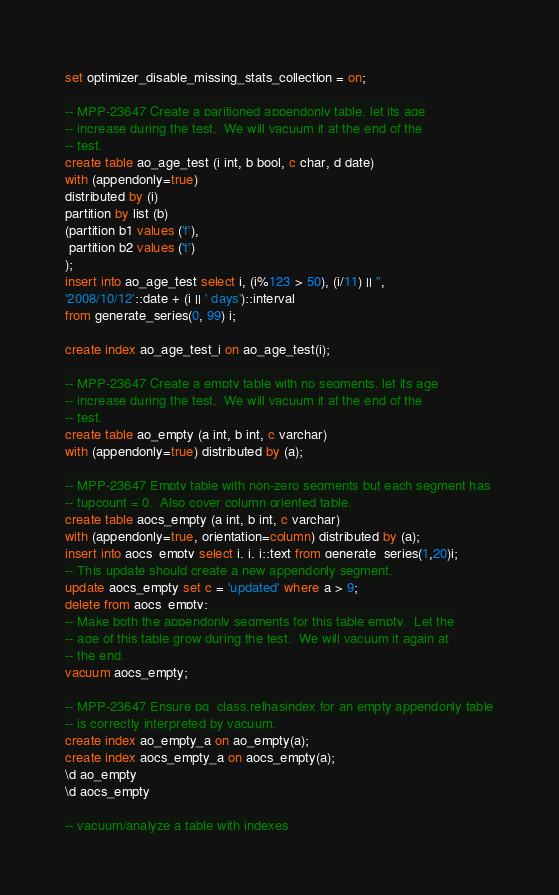Convert code to text. <code><loc_0><loc_0><loc_500><loc_500><_SQL_>set optimizer_disable_missing_stats_collection = on;

-- MPP-23647 Create a paritioned appendonly table, let its age
-- increase during the test.  We will vacuum it at the end of the
-- test.
create table ao_age_test (i int, b bool, c char, d date)
with (appendonly=true)
distributed by (i)
partition by list (b)
(partition b1 values ('f'),
 partition b2 values ('t')
);
insert into ao_age_test select i, (i%123 > 50), (i/11) || '',
'2008/10/12'::date + (i || ' days')::interval
from generate_series(0, 99) i;

create index ao_age_test_i on ao_age_test(i);

-- MPP-23647 Create a empty table with no segments, let its age
-- increase during the test.  We will vacuum it at the end of the
-- test.
create table ao_empty (a int, b int, c varchar)
with (appendonly=true) distributed by (a);

-- MPP-23647 Empty table with non-zero segments but each segment has
-- tupcount = 0.  Also cover column oriented table.
create table aocs_empty (a int, b int, c varchar)
with (appendonly=true, orientation=column) distributed by (a);
insert into aocs_empty select i, i, i::text from generate_series(1,20)i;
-- This update should create a new appendonly segment.
update aocs_empty set c = 'updated' where a > 9;
delete from aocs_empty;
-- Make both the appendonly segments for this table empty.  Let the
-- age of this table grow during the test.  We will vacuum it again at
-- the end.
vacuum aocs_empty;

-- MPP-23647 Ensure pg_class.relhasindex for an empty appendonly table
-- is correctly interpreted by vacuum.
create index ao_empty_a on ao_empty(a);
create index aocs_empty_a on aocs_empty(a);
\d ao_empty
\d aocs_empty

-- vacuum/analyze a table with indexes</code> 